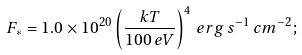Convert formula to latex. <formula><loc_0><loc_0><loc_500><loc_500>F _ { \ast } = 1 . 0 \times 1 0 ^ { 2 0 } \left ( \frac { k T } { 1 0 0 \, e V } \right ) ^ { 4 } \, e r g \, s ^ { - 1 } \, c m ^ { - 2 } ;</formula> 